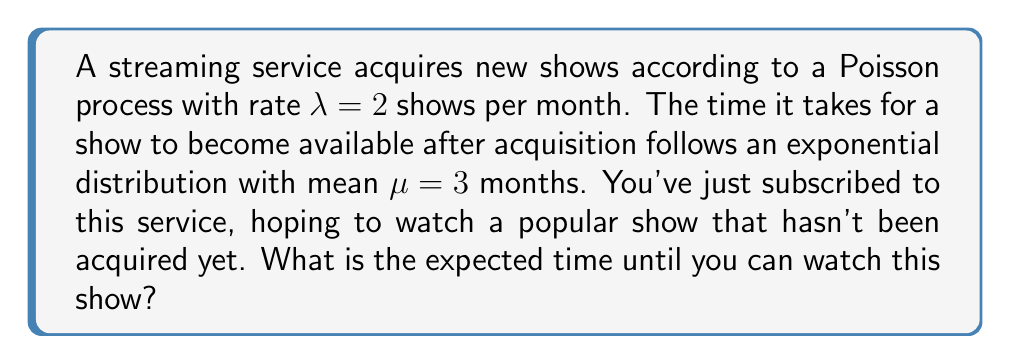Can you answer this question? Let's approach this step-by-step using renewal process theory:

1) The acquisition of shows follows a Poisson process with rate $\lambda = 2$ per month. The time between acquisitions is therefore exponentially distributed with mean $\frac{1}{\lambda} = \frac{1}{2}$ month.

2) After acquisition, the time until a show becomes available is exponentially distributed with mean $\mu = 3$ months.

3) The total time until a show is available is the sum of these two random variables:
   $T = X + Y$, where
   $X \sim Exp(\lambda)$ (time until acquisition)
   $Y \sim Exp(\frac{1}{\mu})$ (time from acquisition to availability)

4) For exponential distributions, we can use the property that the sum of independent exponential random variables follows an Erlang distribution.

5) The expected value of an Erlang distribution is the sum of the expected values of its component exponential distributions:

   $E[T] = E[X] + E[Y] = \frac{1}{\lambda} + \mu = \frac{1}{2} + 3 = 3.5$ months

Therefore, the expected time until you can watch the show is 3.5 months.
Answer: 3.5 months 